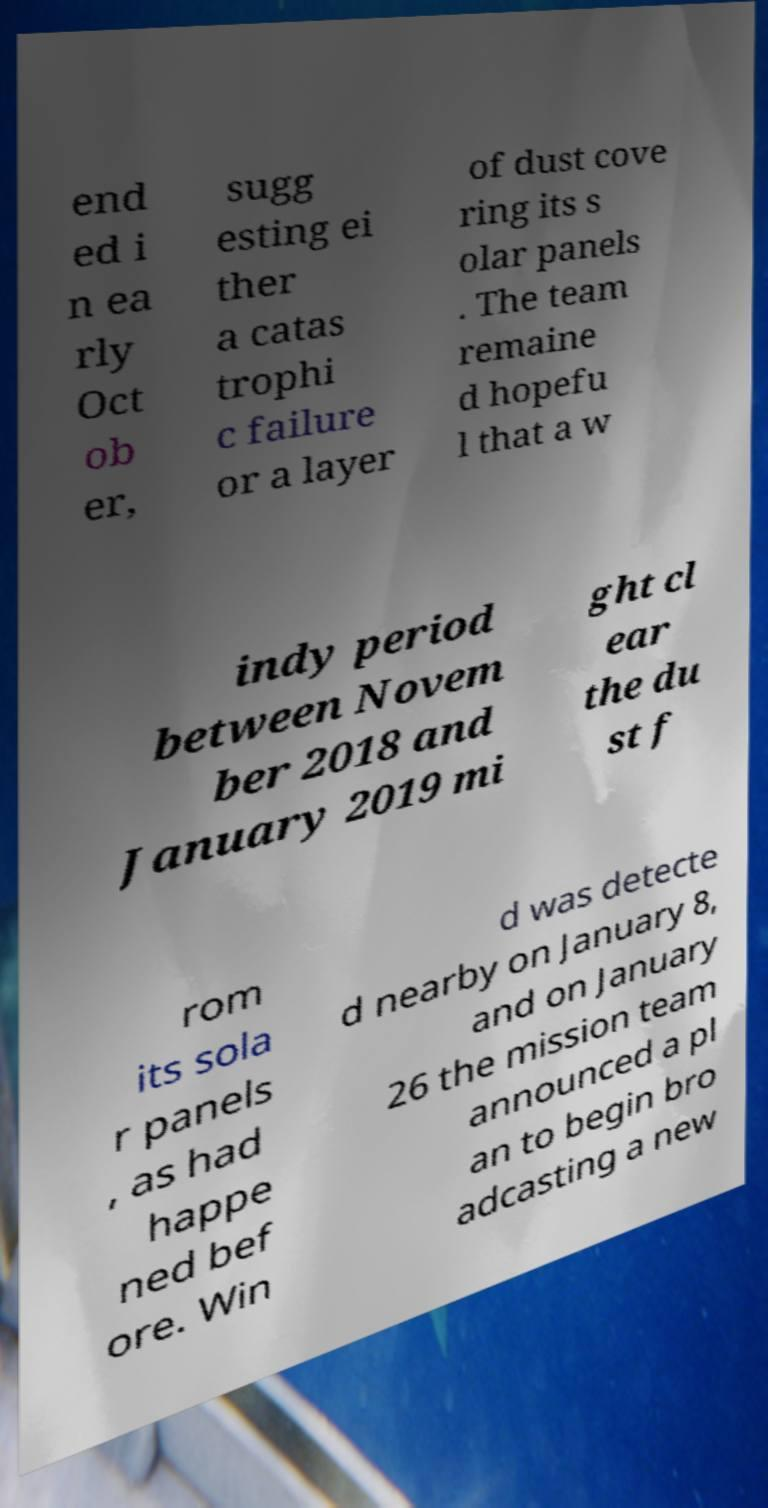I need the written content from this picture converted into text. Can you do that? end ed i n ea rly Oct ob er, sugg esting ei ther a catas trophi c failure or a layer of dust cove ring its s olar panels . The team remaine d hopefu l that a w indy period between Novem ber 2018 and January 2019 mi ght cl ear the du st f rom its sola r panels , as had happe ned bef ore. Win d was detecte d nearby on January 8, and on January 26 the mission team announced a pl an to begin bro adcasting a new 